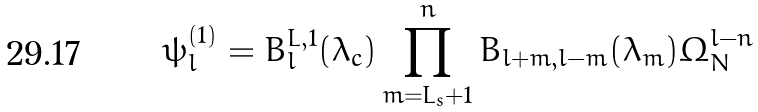<formula> <loc_0><loc_0><loc_500><loc_500>\psi _ { l } ^ { ( 1 ) } = B ^ { L , 1 } _ { l } ( \lambda _ { c } ) \prod _ { m = L _ { s } + 1 } ^ { n } B _ { l + m , l - m } ( \lambda _ { m } ) \Omega _ { N } ^ { l - n }</formula> 